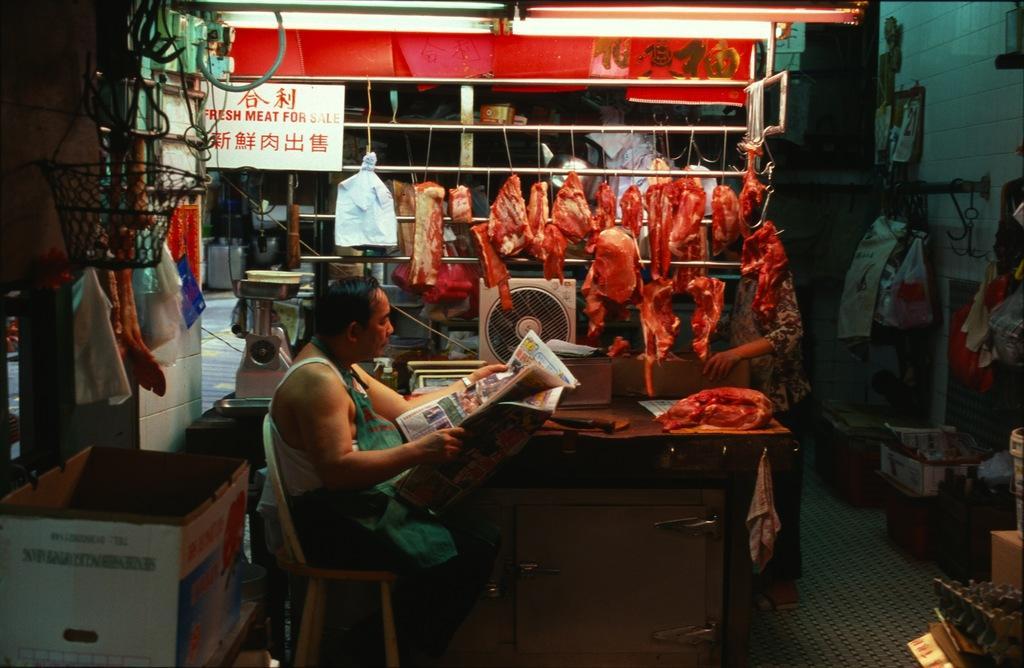Can you describe this image briefly? In the picture I can see a man sitting on the chair and he is holding the newspaper in his hands. I can see a stock box on the bottom left side. I can see the red meat in the middle of the picture. I can see a weighing machine, a fan and a piece of red meat on the wooden drawer. There is a person standing on the floor on the right side. I can see the lights at the top of the picture. 